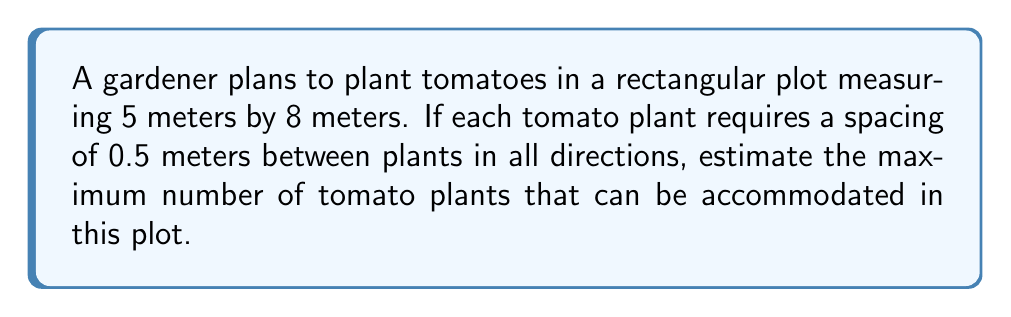Could you help me with this problem? To solve this problem, we need to follow these steps:

1. Calculate the total area of the plot:
   Area = length × width
   $$ A = 5 \text{ m} \times 8 \text{ m} = 40 \text{ m}^2 $$

2. Determine the area required for each plant:
   Each plant needs a 0.5 m × 0.5 m space
   $$ A_{plant} = 0.5 \text{ m} \times 0.5 \text{ m} = 0.25 \text{ m}^2 $$

3. Calculate the number of plants that can fit in the plot:
   $$ \text{Number of plants} = \frac{\text{Total area}}{\text{Area per plant}} $$
   $$ \text{Number of plants} = \frac{40 \text{ m}^2}{0.25 \text{ m}^2} = 160 $$

4. Consider edge effects:
   In reality, we might not be able to fit exactly 160 plants due to edge effects and the need for access paths. A more practical estimate would be slightly less than this theoretical maximum.

Therefore, we can estimate that approximately 150-160 tomato plants can be accommodated in this plot, depending on the exact layout and any additional spacing needed for access.
Answer: Approximately 150-160 tomato plants 